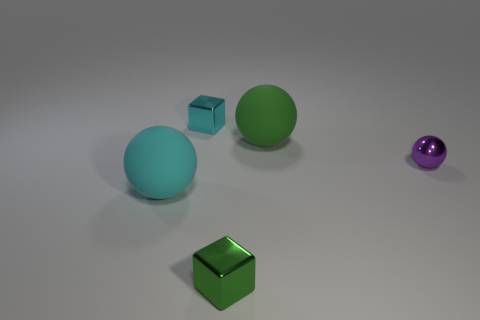Can you tell me what the purple object on the right side of the image is? Certainly! The object on the right side of the image is a small, shiny purple sphere. Its reflective surface suggests it could be made of a material like glass or polished metal. 